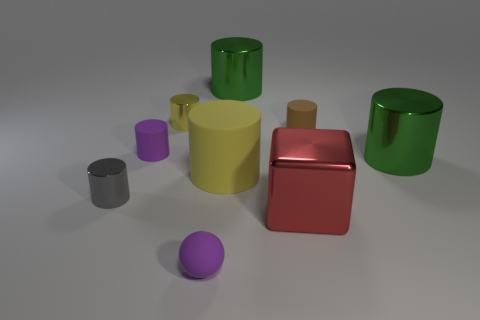Subtract all purple cylinders. How many cylinders are left? 6 Subtract all purple rubber cylinders. How many cylinders are left? 6 Subtract all blue cylinders. Subtract all blue cubes. How many cylinders are left? 7 Add 1 tiny cylinders. How many objects exist? 10 Subtract all blocks. How many objects are left? 8 Subtract all tiny purple matte objects. Subtract all yellow shiny cylinders. How many objects are left? 6 Add 9 big red metallic blocks. How many big red metallic blocks are left? 10 Add 1 large things. How many large things exist? 5 Subtract 0 cyan blocks. How many objects are left? 9 